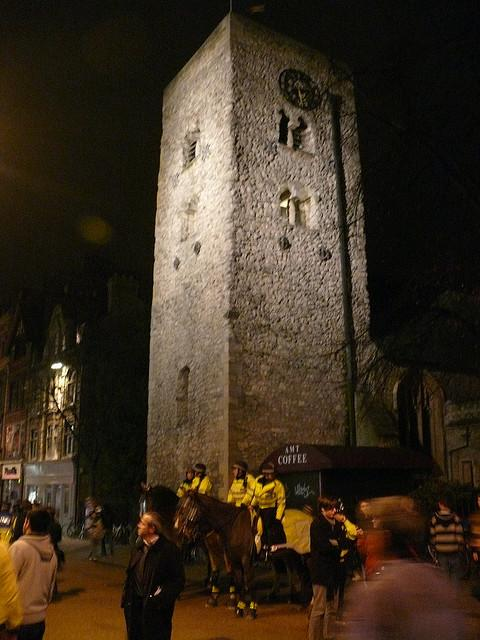What material is the construction of this tower? Please explain your reasoning. cobblestone. The material is cobblestone. 